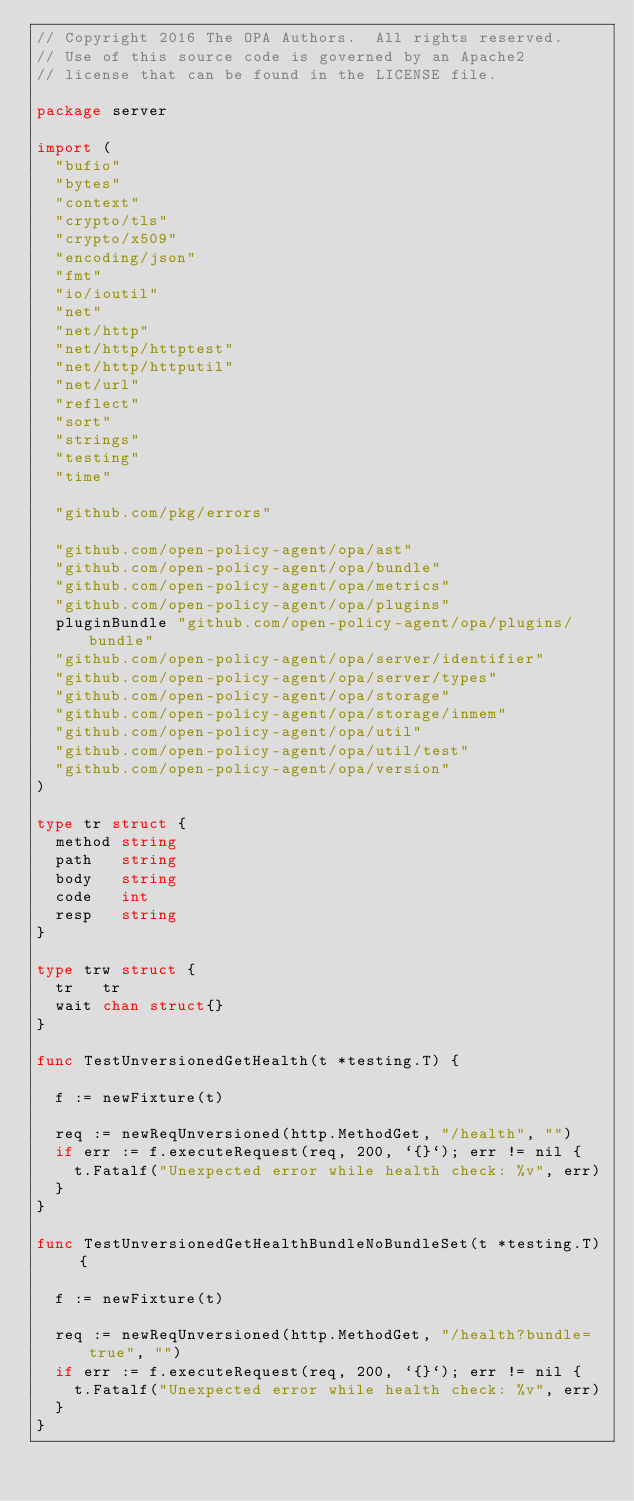Convert code to text. <code><loc_0><loc_0><loc_500><loc_500><_Go_>// Copyright 2016 The OPA Authors.  All rights reserved.
// Use of this source code is governed by an Apache2
// license that can be found in the LICENSE file.

package server

import (
	"bufio"
	"bytes"
	"context"
	"crypto/tls"
	"crypto/x509"
	"encoding/json"
	"fmt"
	"io/ioutil"
	"net"
	"net/http"
	"net/http/httptest"
	"net/http/httputil"
	"net/url"
	"reflect"
	"sort"
	"strings"
	"testing"
	"time"

	"github.com/pkg/errors"

	"github.com/open-policy-agent/opa/ast"
	"github.com/open-policy-agent/opa/bundle"
	"github.com/open-policy-agent/opa/metrics"
	"github.com/open-policy-agent/opa/plugins"
	pluginBundle "github.com/open-policy-agent/opa/plugins/bundle"
	"github.com/open-policy-agent/opa/server/identifier"
	"github.com/open-policy-agent/opa/server/types"
	"github.com/open-policy-agent/opa/storage"
	"github.com/open-policy-agent/opa/storage/inmem"
	"github.com/open-policy-agent/opa/util"
	"github.com/open-policy-agent/opa/util/test"
	"github.com/open-policy-agent/opa/version"
)

type tr struct {
	method string
	path   string
	body   string
	code   int
	resp   string
}

type trw struct {
	tr   tr
	wait chan struct{}
}

func TestUnversionedGetHealth(t *testing.T) {

	f := newFixture(t)

	req := newReqUnversioned(http.MethodGet, "/health", "")
	if err := f.executeRequest(req, 200, `{}`); err != nil {
		t.Fatalf("Unexpected error while health check: %v", err)
	}
}

func TestUnversionedGetHealthBundleNoBundleSet(t *testing.T) {

	f := newFixture(t)

	req := newReqUnversioned(http.MethodGet, "/health?bundle=true", "")
	if err := f.executeRequest(req, 200, `{}`); err != nil {
		t.Fatalf("Unexpected error while health check: %v", err)
	}
}
</code> 